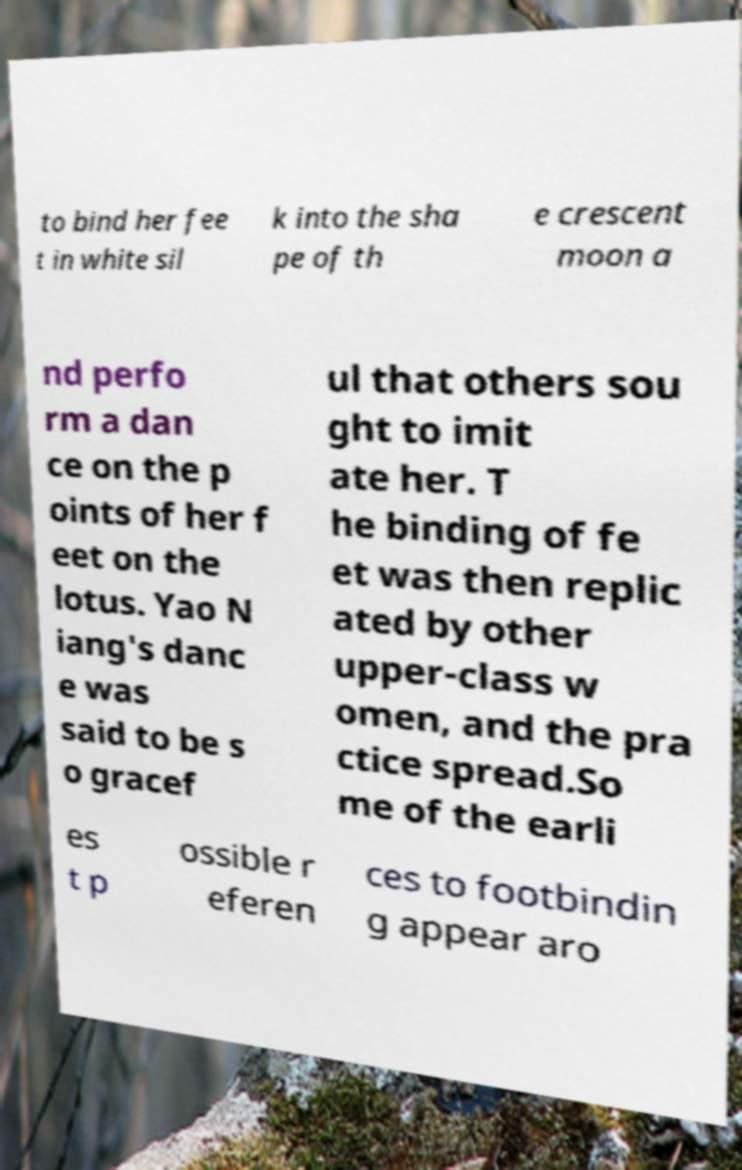Please identify and transcribe the text found in this image. to bind her fee t in white sil k into the sha pe of th e crescent moon a nd perfo rm a dan ce on the p oints of her f eet on the lotus. Yao N iang's danc e was said to be s o gracef ul that others sou ght to imit ate her. T he binding of fe et was then replic ated by other upper-class w omen, and the pra ctice spread.So me of the earli es t p ossible r eferen ces to footbindin g appear aro 